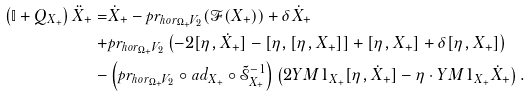<formula> <loc_0><loc_0><loc_500><loc_500>\left ( \mathbb { I } + Q _ { X _ { + } } \right ) \ddot { X } _ { + } = & \dot { X } _ { + } - p r _ { h o r _ { \Omega _ { + } } V _ { 2 } } ( \mathcal { F } ( X _ { + } ) ) + \delta \dot { X } _ { + } \\ + & p r _ { h o r _ { \Omega _ { + } } V _ { 2 } } \left ( - 2 [ \eta , \dot { X } _ { + } ] - [ \eta , [ \eta , X _ { + } ] ] + [ \eta , X _ { + } ] + \delta [ \eta , X _ { + } ] \right ) \\ - & \left ( p r _ { h o r _ { \Omega _ { + } } V _ { 2 } } \circ a d _ { X _ { + } } \circ \tilde { \mathcal { S } } ^ { - 1 } _ { X _ { + } } \right ) \left ( 2 Y M 1 _ { X _ { + } } [ \eta , \dot { X } _ { + } ] - \eta \cdot Y M 1 _ { X _ { + } } \dot { X } _ { + } \right ) .</formula> 